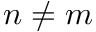<formula> <loc_0><loc_0><loc_500><loc_500>n \neq m</formula> 